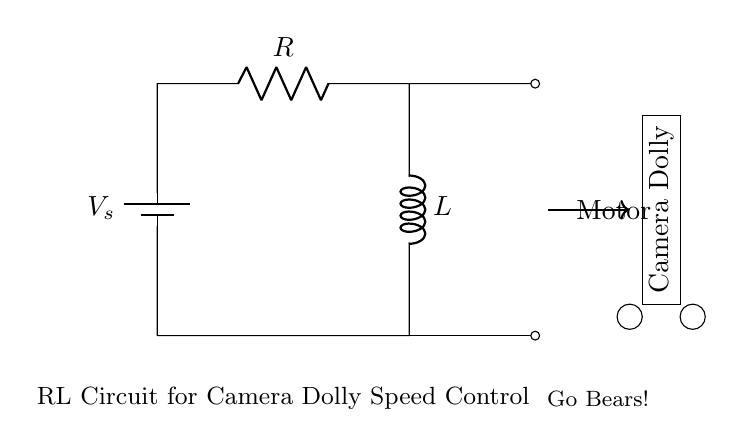What is the voltage source in the circuit? The voltage source is labeled as V_s, indicating it's the primary power supply for the circuit.
Answer: V_s What components are present in the circuit? The circuit contains a resistor (R), an inductor (L), and a voltage source (V_s). These components are connected in series as shown in the diagram.
Answer: Resistor, Inductor, Voltage source What type of motor is being used? The circuit diagram does not specify a type of motor, but indicates that it is used to control the speed of a motorized camera dolly.
Answer: Motor What is the arrangement of the components? The components are arranged in a series configuration where the voltage source connects to the resistor which is followed by the inductor.
Answer: Series How does the inductor affect the circuit's performance? The inductor stores energy in a magnetic field when current passes through it, which helps in smoothening the current flow and controlling the speed of the motor. This dynamic is critical in motor applications for smooth operations.
Answer: Smooths current flow What is the purpose of the resistor in this circuit? The resistor limits the current flow in the circuit, which also affects the voltage drop across the inductor and thus assists in managing the speed of the motor.
Answer: Limits current flow 